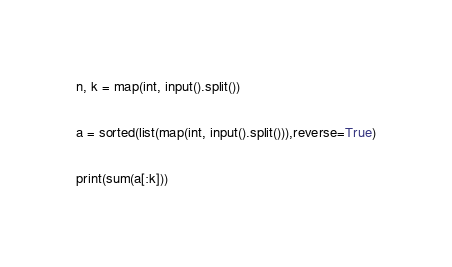Convert code to text. <code><loc_0><loc_0><loc_500><loc_500><_Python_>n, k = map(int, input().split())

a = sorted(list(map(int, input().split())),reverse=True)

print(sum(a[:k]))
</code> 